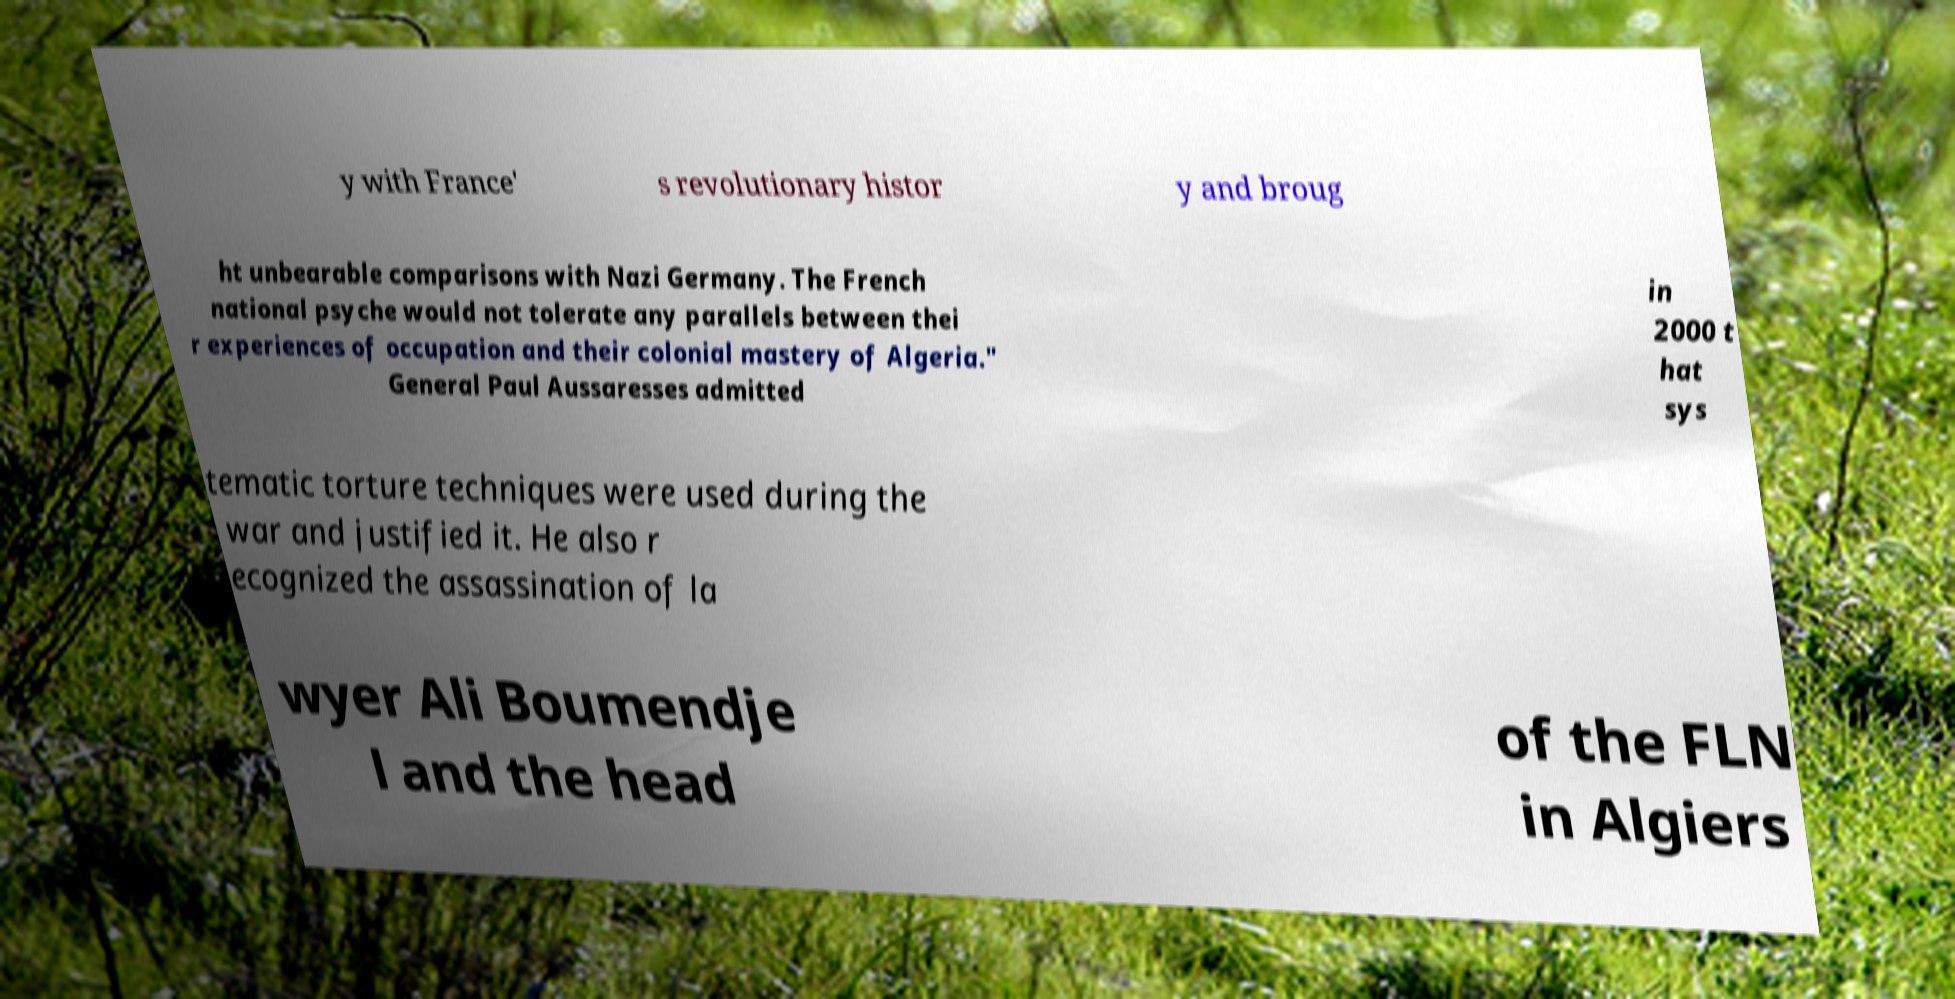What messages or text are displayed in this image? I need them in a readable, typed format. y with France' s revolutionary histor y and broug ht unbearable comparisons with Nazi Germany. The French national psyche would not tolerate any parallels between thei r experiences of occupation and their colonial mastery of Algeria." General Paul Aussaresses admitted in 2000 t hat sys tematic torture techniques were used during the war and justified it. He also r ecognized the assassination of la wyer Ali Boumendje l and the head of the FLN in Algiers 